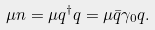<formula> <loc_0><loc_0><loc_500><loc_500>\mu n = \mu q ^ { \dagger } q = \mu \bar { q } \gamma _ { 0 } q .</formula> 